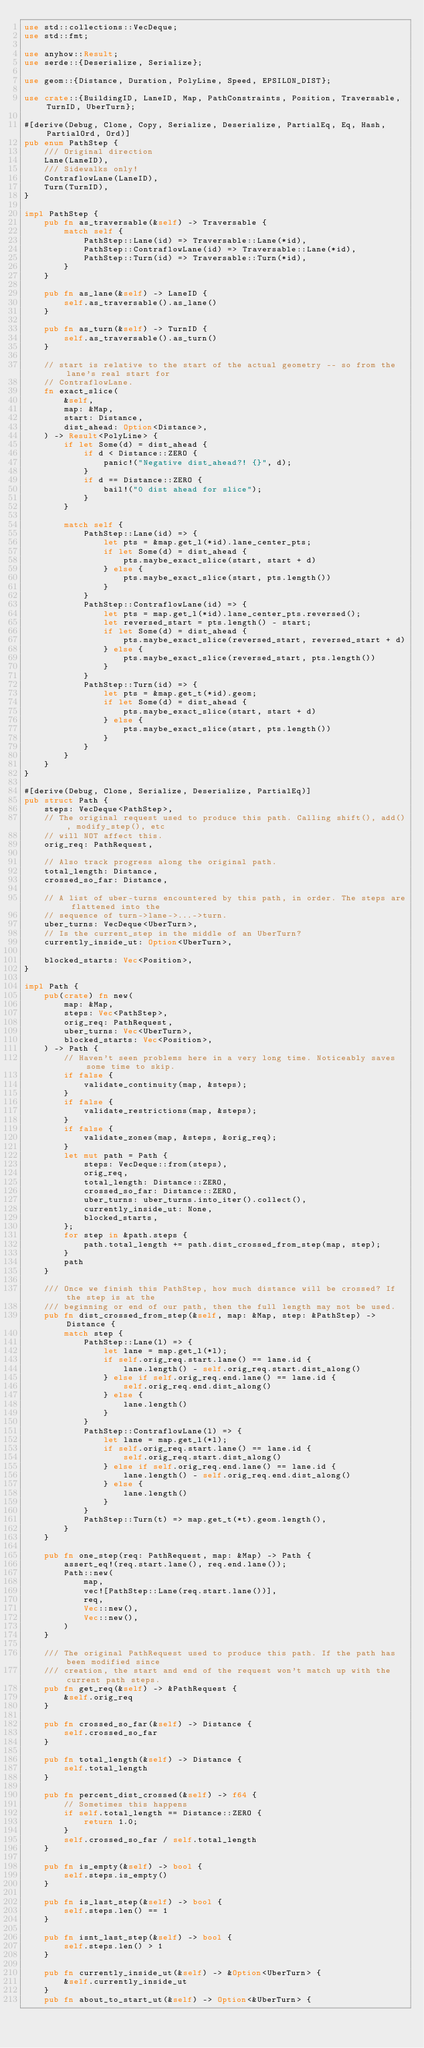Convert code to text. <code><loc_0><loc_0><loc_500><loc_500><_Rust_>use std::collections::VecDeque;
use std::fmt;

use anyhow::Result;
use serde::{Deserialize, Serialize};

use geom::{Distance, Duration, PolyLine, Speed, EPSILON_DIST};

use crate::{BuildingID, LaneID, Map, PathConstraints, Position, Traversable, TurnID, UberTurn};

#[derive(Debug, Clone, Copy, Serialize, Deserialize, PartialEq, Eq, Hash, PartialOrd, Ord)]
pub enum PathStep {
    /// Original direction
    Lane(LaneID),
    /// Sidewalks only!
    ContraflowLane(LaneID),
    Turn(TurnID),
}

impl PathStep {
    pub fn as_traversable(&self) -> Traversable {
        match self {
            PathStep::Lane(id) => Traversable::Lane(*id),
            PathStep::ContraflowLane(id) => Traversable::Lane(*id),
            PathStep::Turn(id) => Traversable::Turn(*id),
        }
    }

    pub fn as_lane(&self) -> LaneID {
        self.as_traversable().as_lane()
    }

    pub fn as_turn(&self) -> TurnID {
        self.as_traversable().as_turn()
    }

    // start is relative to the start of the actual geometry -- so from the lane's real start for
    // ContraflowLane.
    fn exact_slice(
        &self,
        map: &Map,
        start: Distance,
        dist_ahead: Option<Distance>,
    ) -> Result<PolyLine> {
        if let Some(d) = dist_ahead {
            if d < Distance::ZERO {
                panic!("Negative dist_ahead?! {}", d);
            }
            if d == Distance::ZERO {
                bail!("0 dist ahead for slice");
            }
        }

        match self {
            PathStep::Lane(id) => {
                let pts = &map.get_l(*id).lane_center_pts;
                if let Some(d) = dist_ahead {
                    pts.maybe_exact_slice(start, start + d)
                } else {
                    pts.maybe_exact_slice(start, pts.length())
                }
            }
            PathStep::ContraflowLane(id) => {
                let pts = map.get_l(*id).lane_center_pts.reversed();
                let reversed_start = pts.length() - start;
                if let Some(d) = dist_ahead {
                    pts.maybe_exact_slice(reversed_start, reversed_start + d)
                } else {
                    pts.maybe_exact_slice(reversed_start, pts.length())
                }
            }
            PathStep::Turn(id) => {
                let pts = &map.get_t(*id).geom;
                if let Some(d) = dist_ahead {
                    pts.maybe_exact_slice(start, start + d)
                } else {
                    pts.maybe_exact_slice(start, pts.length())
                }
            }
        }
    }
}

#[derive(Debug, Clone, Serialize, Deserialize, PartialEq)]
pub struct Path {
    steps: VecDeque<PathStep>,
    // The original request used to produce this path. Calling shift(), add(), modify_step(), etc
    // will NOT affect this.
    orig_req: PathRequest,

    // Also track progress along the original path.
    total_length: Distance,
    crossed_so_far: Distance,

    // A list of uber-turns encountered by this path, in order. The steps are flattened into the
    // sequence of turn->lane->...->turn.
    uber_turns: VecDeque<UberTurn>,
    // Is the current_step in the middle of an UberTurn?
    currently_inside_ut: Option<UberTurn>,

    blocked_starts: Vec<Position>,
}

impl Path {
    pub(crate) fn new(
        map: &Map,
        steps: Vec<PathStep>,
        orig_req: PathRequest,
        uber_turns: Vec<UberTurn>,
        blocked_starts: Vec<Position>,
    ) -> Path {
        // Haven't seen problems here in a very long time. Noticeably saves some time to skip.
        if false {
            validate_continuity(map, &steps);
        }
        if false {
            validate_restrictions(map, &steps);
        }
        if false {
            validate_zones(map, &steps, &orig_req);
        }
        let mut path = Path {
            steps: VecDeque::from(steps),
            orig_req,
            total_length: Distance::ZERO,
            crossed_so_far: Distance::ZERO,
            uber_turns: uber_turns.into_iter().collect(),
            currently_inside_ut: None,
            blocked_starts,
        };
        for step in &path.steps {
            path.total_length += path.dist_crossed_from_step(map, step);
        }
        path
    }

    /// Once we finish this PathStep, how much distance will be crossed? If the step is at the
    /// beginning or end of our path, then the full length may not be used.
    pub fn dist_crossed_from_step(&self, map: &Map, step: &PathStep) -> Distance {
        match step {
            PathStep::Lane(l) => {
                let lane = map.get_l(*l);
                if self.orig_req.start.lane() == lane.id {
                    lane.length() - self.orig_req.start.dist_along()
                } else if self.orig_req.end.lane() == lane.id {
                    self.orig_req.end.dist_along()
                } else {
                    lane.length()
                }
            }
            PathStep::ContraflowLane(l) => {
                let lane = map.get_l(*l);
                if self.orig_req.start.lane() == lane.id {
                    self.orig_req.start.dist_along()
                } else if self.orig_req.end.lane() == lane.id {
                    lane.length() - self.orig_req.end.dist_along()
                } else {
                    lane.length()
                }
            }
            PathStep::Turn(t) => map.get_t(*t).geom.length(),
        }
    }

    pub fn one_step(req: PathRequest, map: &Map) -> Path {
        assert_eq!(req.start.lane(), req.end.lane());
        Path::new(
            map,
            vec![PathStep::Lane(req.start.lane())],
            req,
            Vec::new(),
            Vec::new(),
        )
    }

    /// The original PathRequest used to produce this path. If the path has been modified since
    /// creation, the start and end of the request won't match up with the current path steps.
    pub fn get_req(&self) -> &PathRequest {
        &self.orig_req
    }

    pub fn crossed_so_far(&self) -> Distance {
        self.crossed_so_far
    }

    pub fn total_length(&self) -> Distance {
        self.total_length
    }

    pub fn percent_dist_crossed(&self) -> f64 {
        // Sometimes this happens
        if self.total_length == Distance::ZERO {
            return 1.0;
        }
        self.crossed_so_far / self.total_length
    }

    pub fn is_empty(&self) -> bool {
        self.steps.is_empty()
    }

    pub fn is_last_step(&self) -> bool {
        self.steps.len() == 1
    }

    pub fn isnt_last_step(&self) -> bool {
        self.steps.len() > 1
    }

    pub fn currently_inside_ut(&self) -> &Option<UberTurn> {
        &self.currently_inside_ut
    }
    pub fn about_to_start_ut(&self) -> Option<&UberTurn> {</code> 